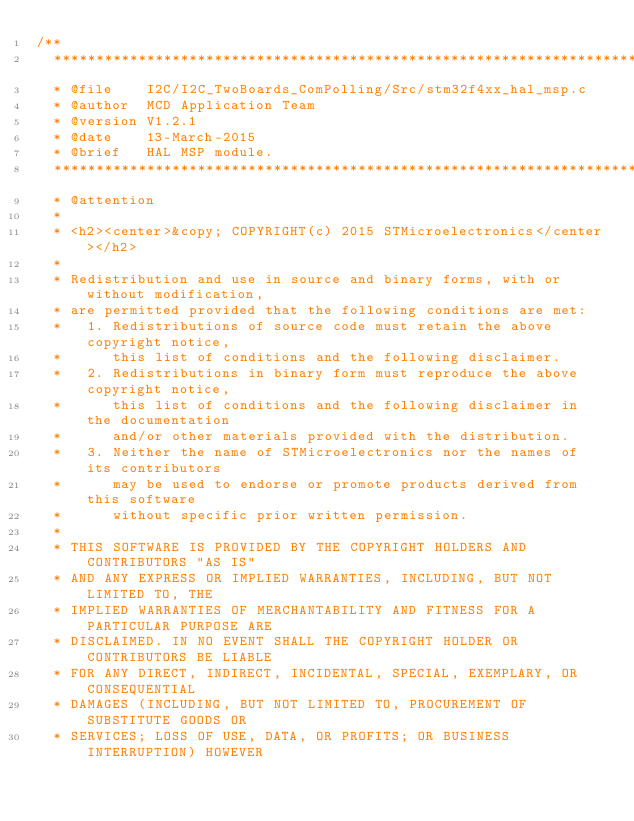Convert code to text. <code><loc_0><loc_0><loc_500><loc_500><_C_>/**
  ******************************************************************************
  * @file    I2C/I2C_TwoBoards_ComPolling/Src/stm32f4xx_hal_msp.c
  * @author  MCD Application Team
  * @version V1.2.1
  * @date    13-March-2015
  * @brief   HAL MSP module.    
  ******************************************************************************
  * @attention
  *
  * <h2><center>&copy; COPYRIGHT(c) 2015 STMicroelectronics</center></h2>
  *
  * Redistribution and use in source and binary forms, with or without modification,
  * are permitted provided that the following conditions are met:
  *   1. Redistributions of source code must retain the above copyright notice,
  *      this list of conditions and the following disclaimer.
  *   2. Redistributions in binary form must reproduce the above copyright notice,
  *      this list of conditions and the following disclaimer in the documentation
  *      and/or other materials provided with the distribution.
  *   3. Neither the name of STMicroelectronics nor the names of its contributors
  *      may be used to endorse or promote products derived from this software
  *      without specific prior written permission.
  *
  * THIS SOFTWARE IS PROVIDED BY THE COPYRIGHT HOLDERS AND CONTRIBUTORS "AS IS"
  * AND ANY EXPRESS OR IMPLIED WARRANTIES, INCLUDING, BUT NOT LIMITED TO, THE
  * IMPLIED WARRANTIES OF MERCHANTABILITY AND FITNESS FOR A PARTICULAR PURPOSE ARE
  * DISCLAIMED. IN NO EVENT SHALL THE COPYRIGHT HOLDER OR CONTRIBUTORS BE LIABLE
  * FOR ANY DIRECT, INDIRECT, INCIDENTAL, SPECIAL, EXEMPLARY, OR CONSEQUENTIAL
  * DAMAGES (INCLUDING, BUT NOT LIMITED TO, PROCUREMENT OF SUBSTITUTE GOODS OR
  * SERVICES; LOSS OF USE, DATA, OR PROFITS; OR BUSINESS INTERRUPTION) HOWEVER</code> 